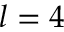<formula> <loc_0><loc_0><loc_500><loc_500>l = 4</formula> 